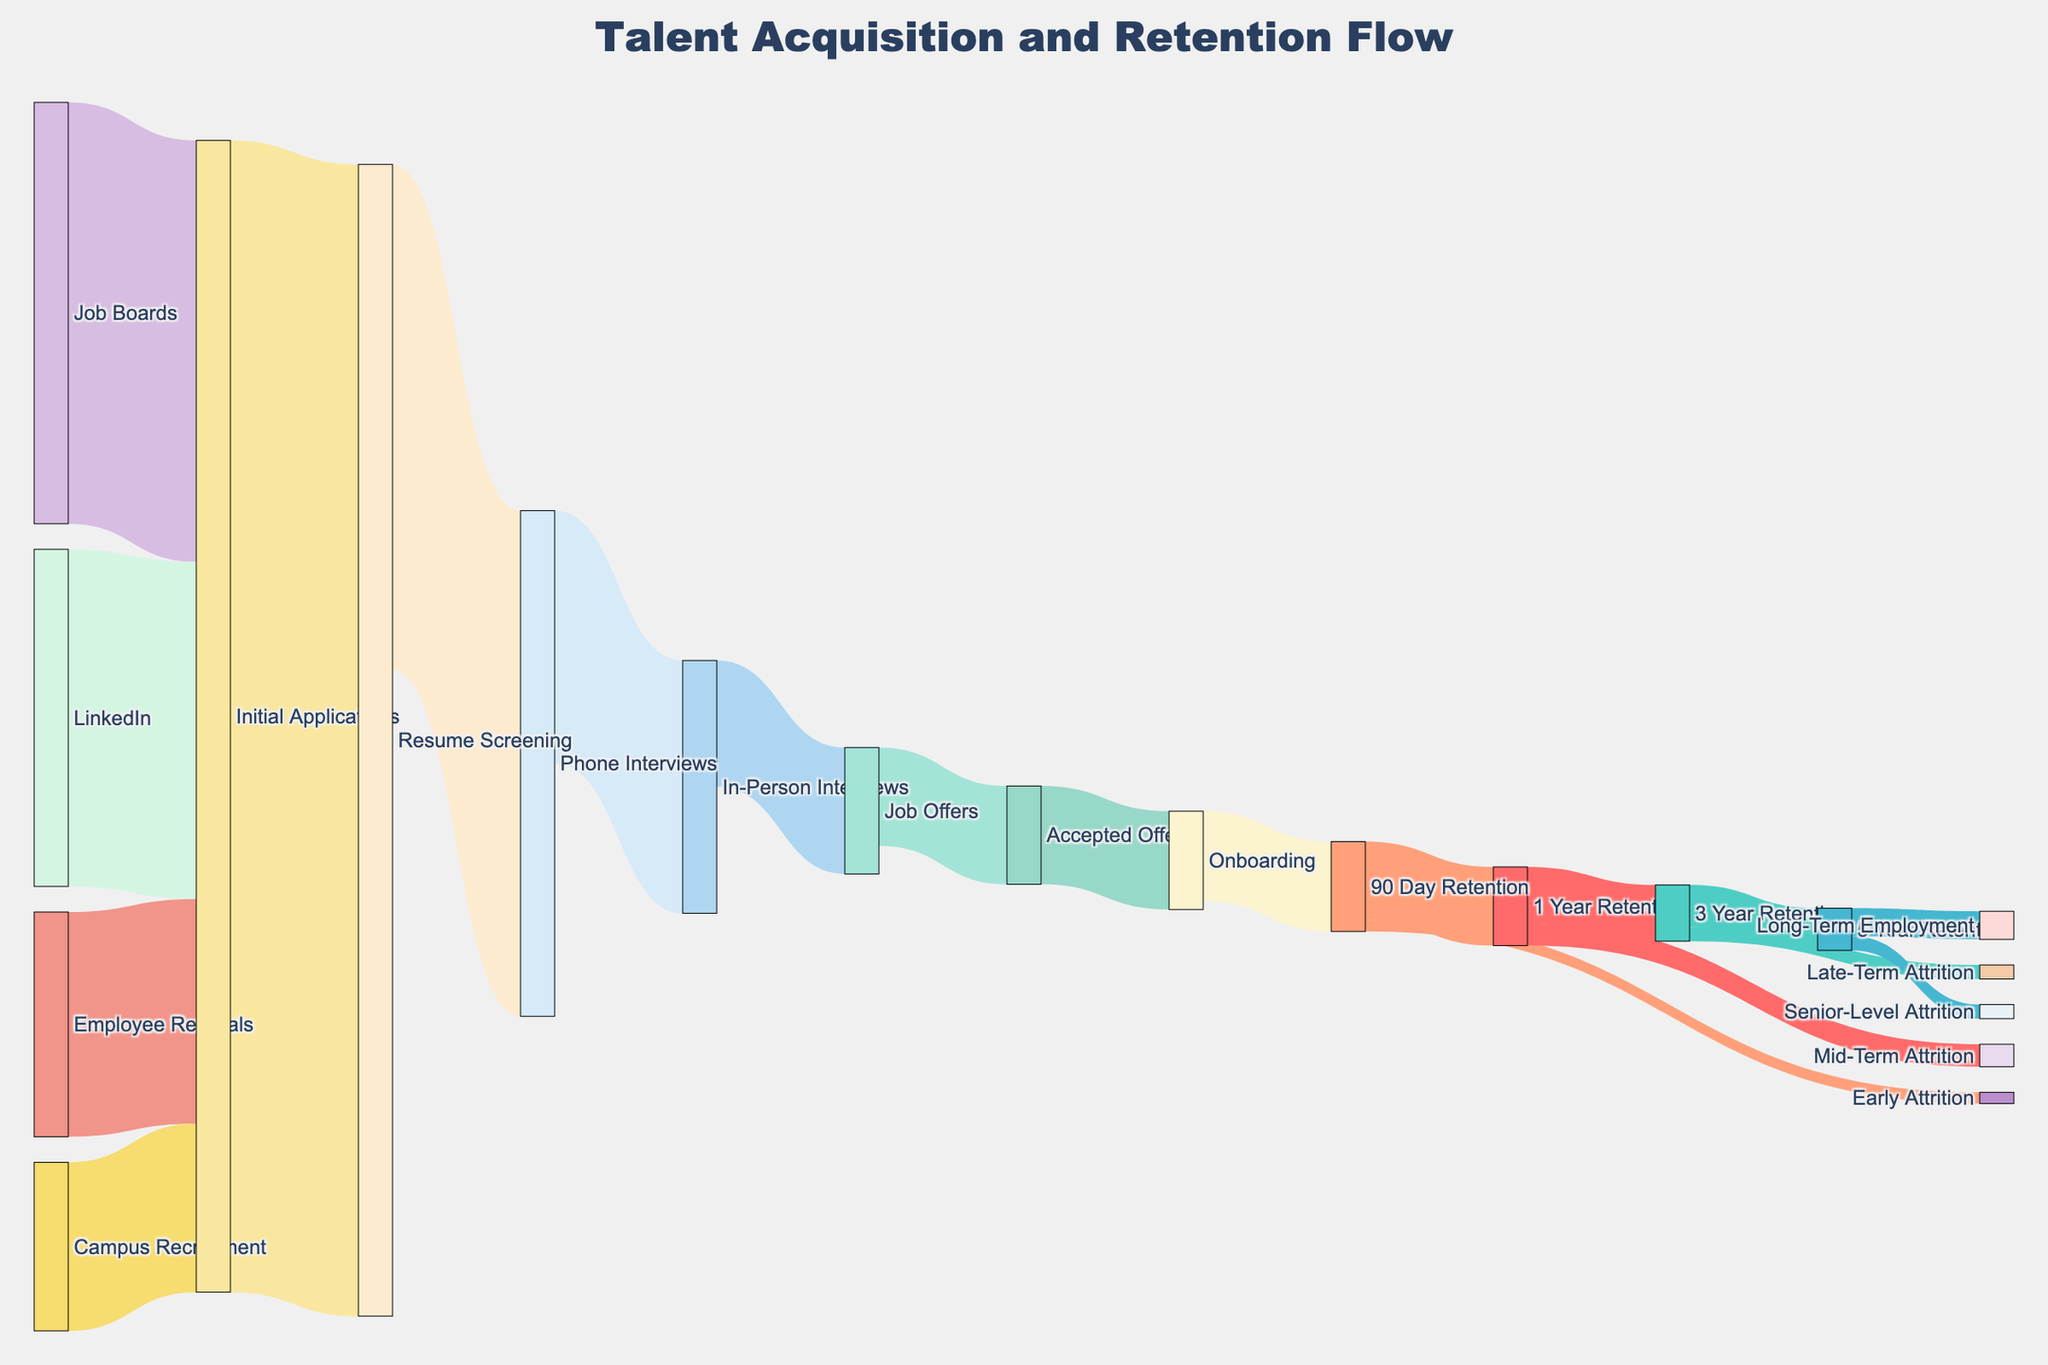What are the primary sources of initial applications? The primary sources of initial applications can be identified by looking at the nodes on the left side of the Sankey diagram. These sources are "Job Boards," "Employee Referrals," "Campus Recruitment," and "LinkedIn."
Answer: Job Boards, Employee Referrals, Campus Recruitment, LinkedIn How many initial applications come from LinkedIn? By checking the flow labeled "LinkedIn" to "Initial Applications," we can see that the value is 1200.
Answer: 1200 What color represents the "Resume Screening" stage? Each stage is represented by a different color in the Sankey diagram. To find the color corresponding to "Resume Screening," look at the node labeled "Resume Screening."
Answer: Light red (approximately) How many candidates move to "Phone Interviews" after "Resume Screening"? The flow from "Resume Screening" to "Phone Interviews" indicates how many candidates advance to the phone interview stage. This is represented by a value on the link between these two nodes.
Answer: 1800 What's the difference between the number of initial applications and the number of 90 Day Retentions? Calculate the difference between the sum of initial applications (4100) and the number of candidates retained at 90 days (320). 4100 - 320 = 3780.
Answer: 3780 Which recruitment source contributes the most to initial applications? Compare the values of the flows from each recruitment source to "Initial Applications." "Job Boards" contribute the most with 1500 applications.
Answer: Job Boards Is the number of "Accepted Offers" more or less than the number of "3 Year Retentions"? Compare the values for "Accepted Offers" (350) and "3 Year Retentions" (200). Since 350 is greater than 200, there are more accepted offers than three-year retentions.
Answer: More Which stage experiences the highest rate of attrition? To find the highest rate of attrition, look for the widest link (flow) that represents candidates leaving. Count and compare the attrition values: Early Attrition (40), Mid-Term Attrition (80), Late-Term Attrition (50), Senior-Level Attrition (50). The highest attrition occurs at the 1 Year Retention stage with Mid-Term Attrition of 80.
Answer: 1 Year Retention What percentage of candidates from "Accepted Offers" reach "Long-Term Employment"? To calculate this, first find the number of candidates accepting offers (350) and the number that reach long-term employment (100). Then, (100 / 350) * 100 = approximately 28.57%.
Answer: ~28.57% 